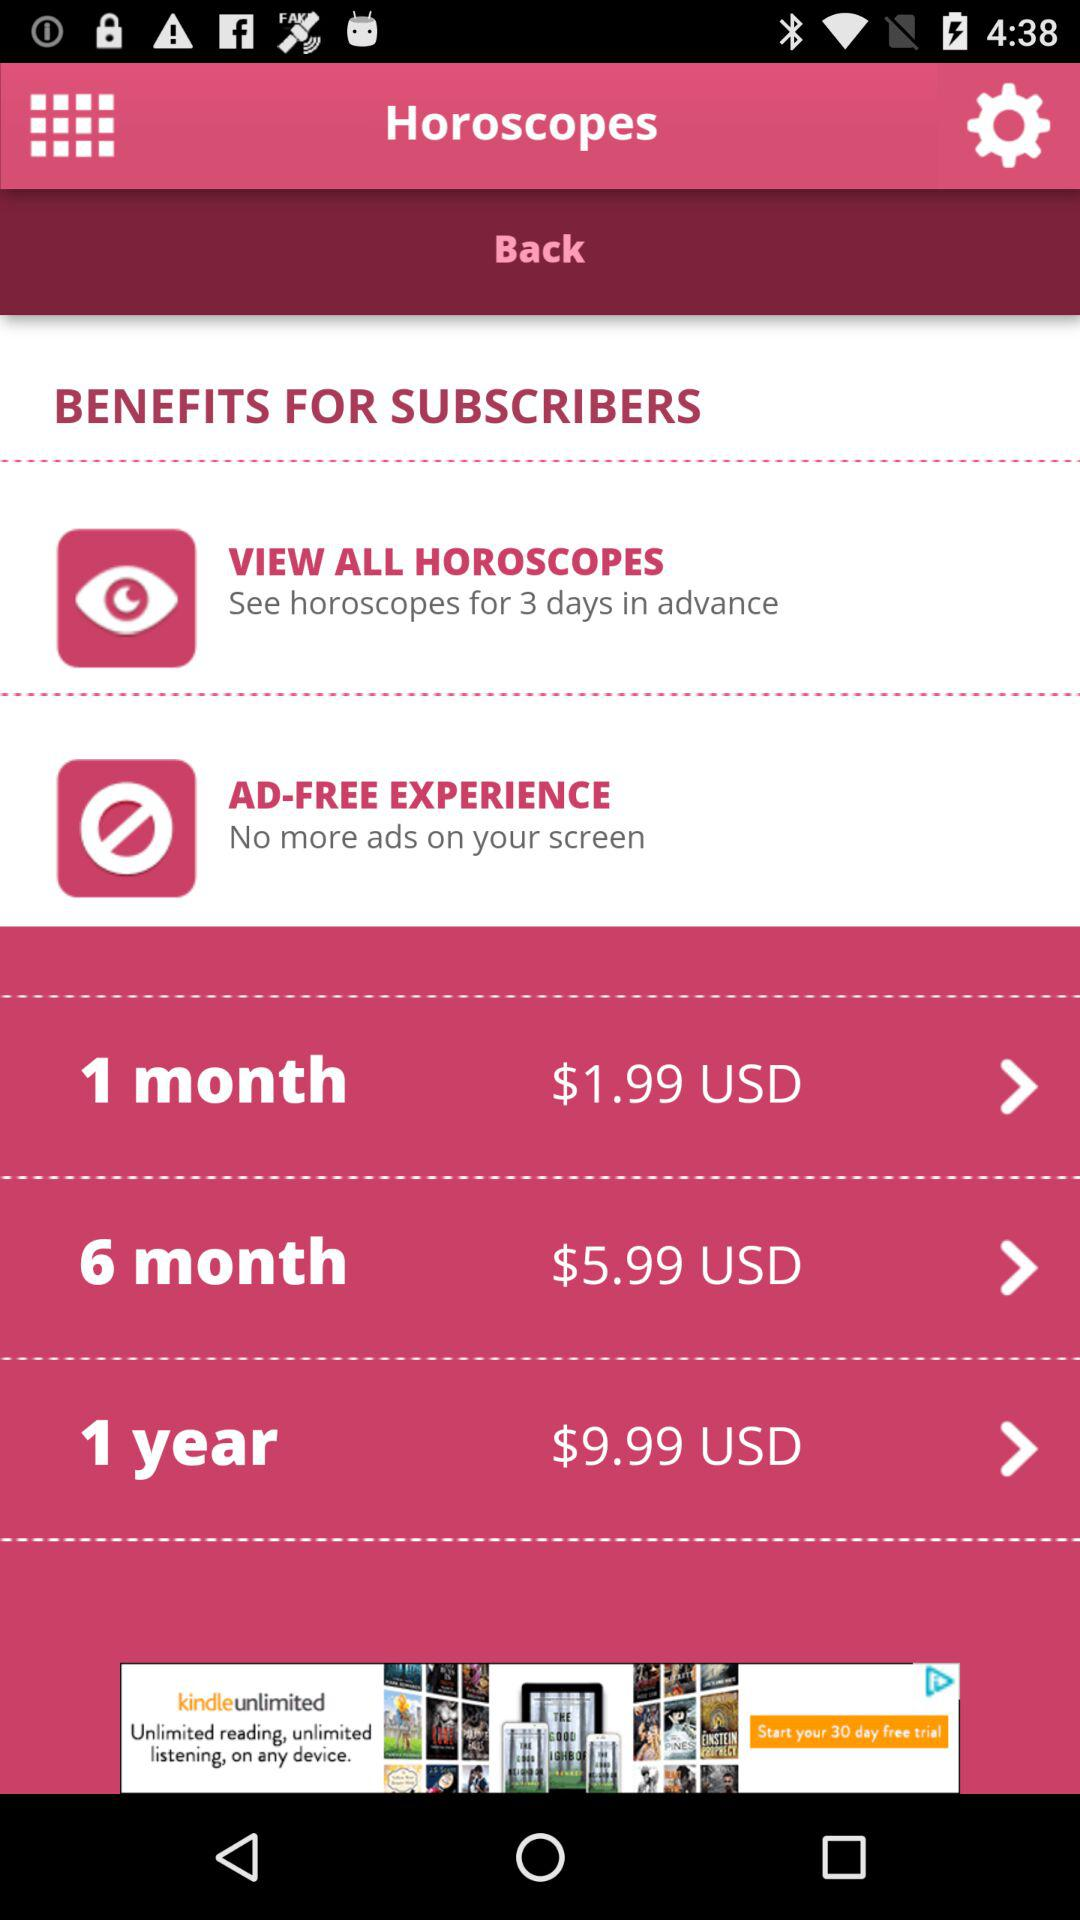How much more does the 1 year subscription cost than the 6 month subscription?
Answer the question using a single word or phrase. $4.00 USD 